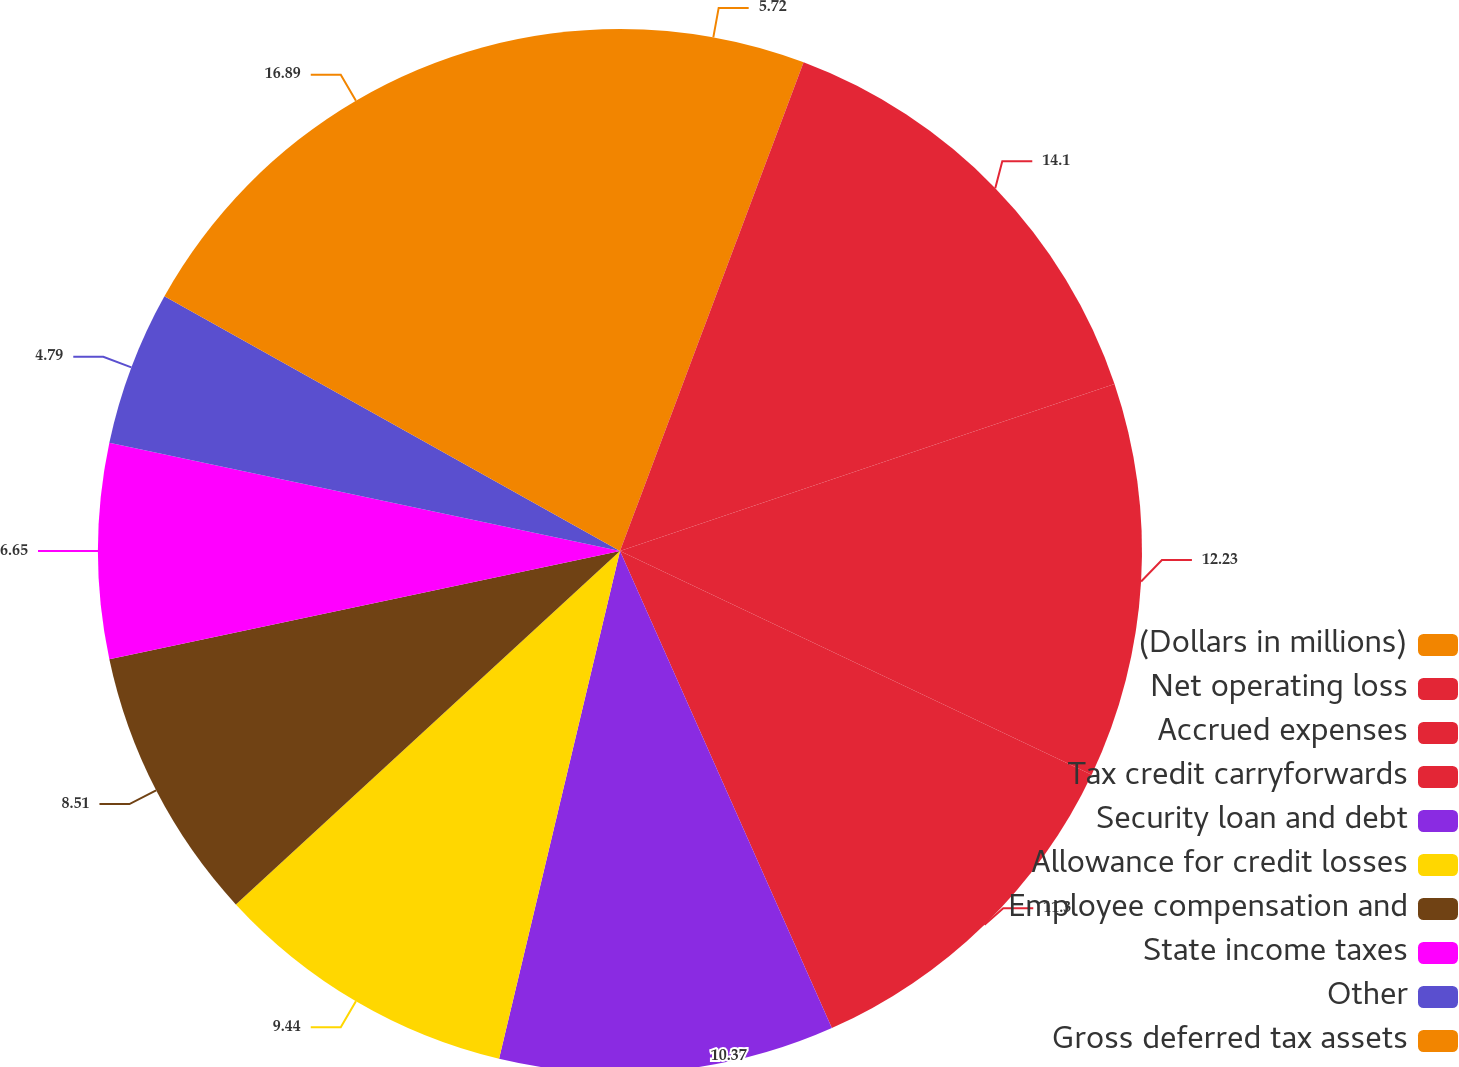<chart> <loc_0><loc_0><loc_500><loc_500><pie_chart><fcel>(Dollars in millions)<fcel>Net operating loss<fcel>Accrued expenses<fcel>Tax credit carryforwards<fcel>Security loan and debt<fcel>Allowance for credit losses<fcel>Employee compensation and<fcel>State income taxes<fcel>Other<fcel>Gross deferred tax assets<nl><fcel>5.72%<fcel>14.09%<fcel>12.23%<fcel>11.3%<fcel>10.37%<fcel>9.44%<fcel>8.51%<fcel>6.65%<fcel>4.79%<fcel>16.88%<nl></chart> 